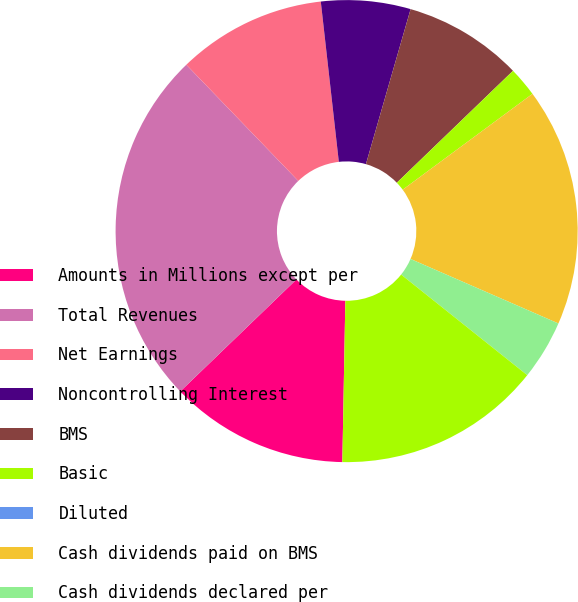Convert chart. <chart><loc_0><loc_0><loc_500><loc_500><pie_chart><fcel>Amounts in Millions except per<fcel>Total Revenues<fcel>Net Earnings<fcel>Noncontrolling Interest<fcel>BMS<fcel>Basic<fcel>Diluted<fcel>Cash dividends paid on BMS<fcel>Cash dividends declared per<fcel>Cash and cash equivalents<nl><fcel>12.5%<fcel>25.0%<fcel>10.42%<fcel>6.25%<fcel>8.33%<fcel>2.08%<fcel>0.0%<fcel>16.67%<fcel>4.17%<fcel>14.58%<nl></chart> 